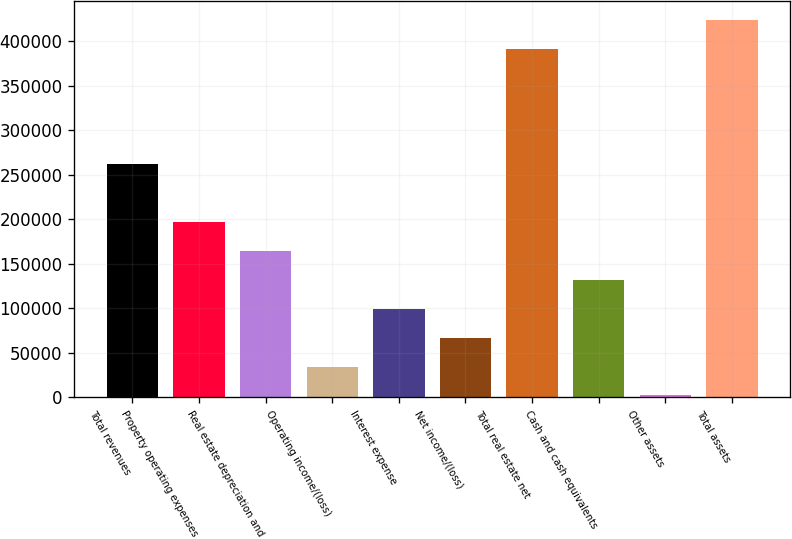<chart> <loc_0><loc_0><loc_500><loc_500><bar_chart><fcel>Total revenues<fcel>Property operating expenses<fcel>Real estate depreciation and<fcel>Operating income/(loss)<fcel>Interest expense<fcel>Net income/(loss)<fcel>Total real estate net<fcel>Cash and cash equivalents<fcel>Other assets<fcel>Total assets<nl><fcel>261766<fcel>196885<fcel>164444<fcel>34681.6<fcel>99562.8<fcel>67122.2<fcel>391528<fcel>132003<fcel>2241<fcel>423969<nl></chart> 